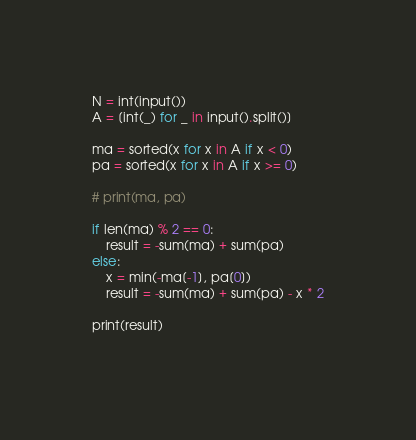Convert code to text. <code><loc_0><loc_0><loc_500><loc_500><_Python_>N = int(input())
A = [int(_) for _ in input().split()]

ma = sorted(x for x in A if x < 0)
pa = sorted(x for x in A if x >= 0)

# print(ma, pa)

if len(ma) % 2 == 0:
    result = -sum(ma) + sum(pa)
else:
    x = min(-ma[-1], pa[0])
    result = -sum(ma) + sum(pa) - x * 2

print(result)
   </code> 